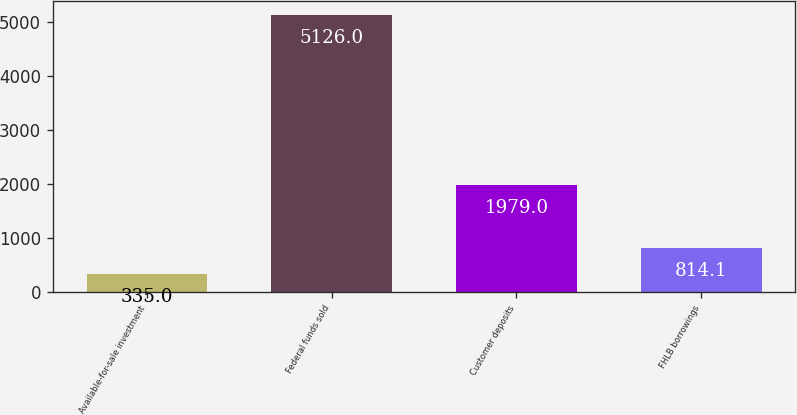Convert chart to OTSL. <chart><loc_0><loc_0><loc_500><loc_500><bar_chart><fcel>Available-for-sale investment<fcel>Federal funds sold<fcel>Customer deposits<fcel>FHLB borrowings<nl><fcel>335<fcel>5126<fcel>1979<fcel>814.1<nl></chart> 